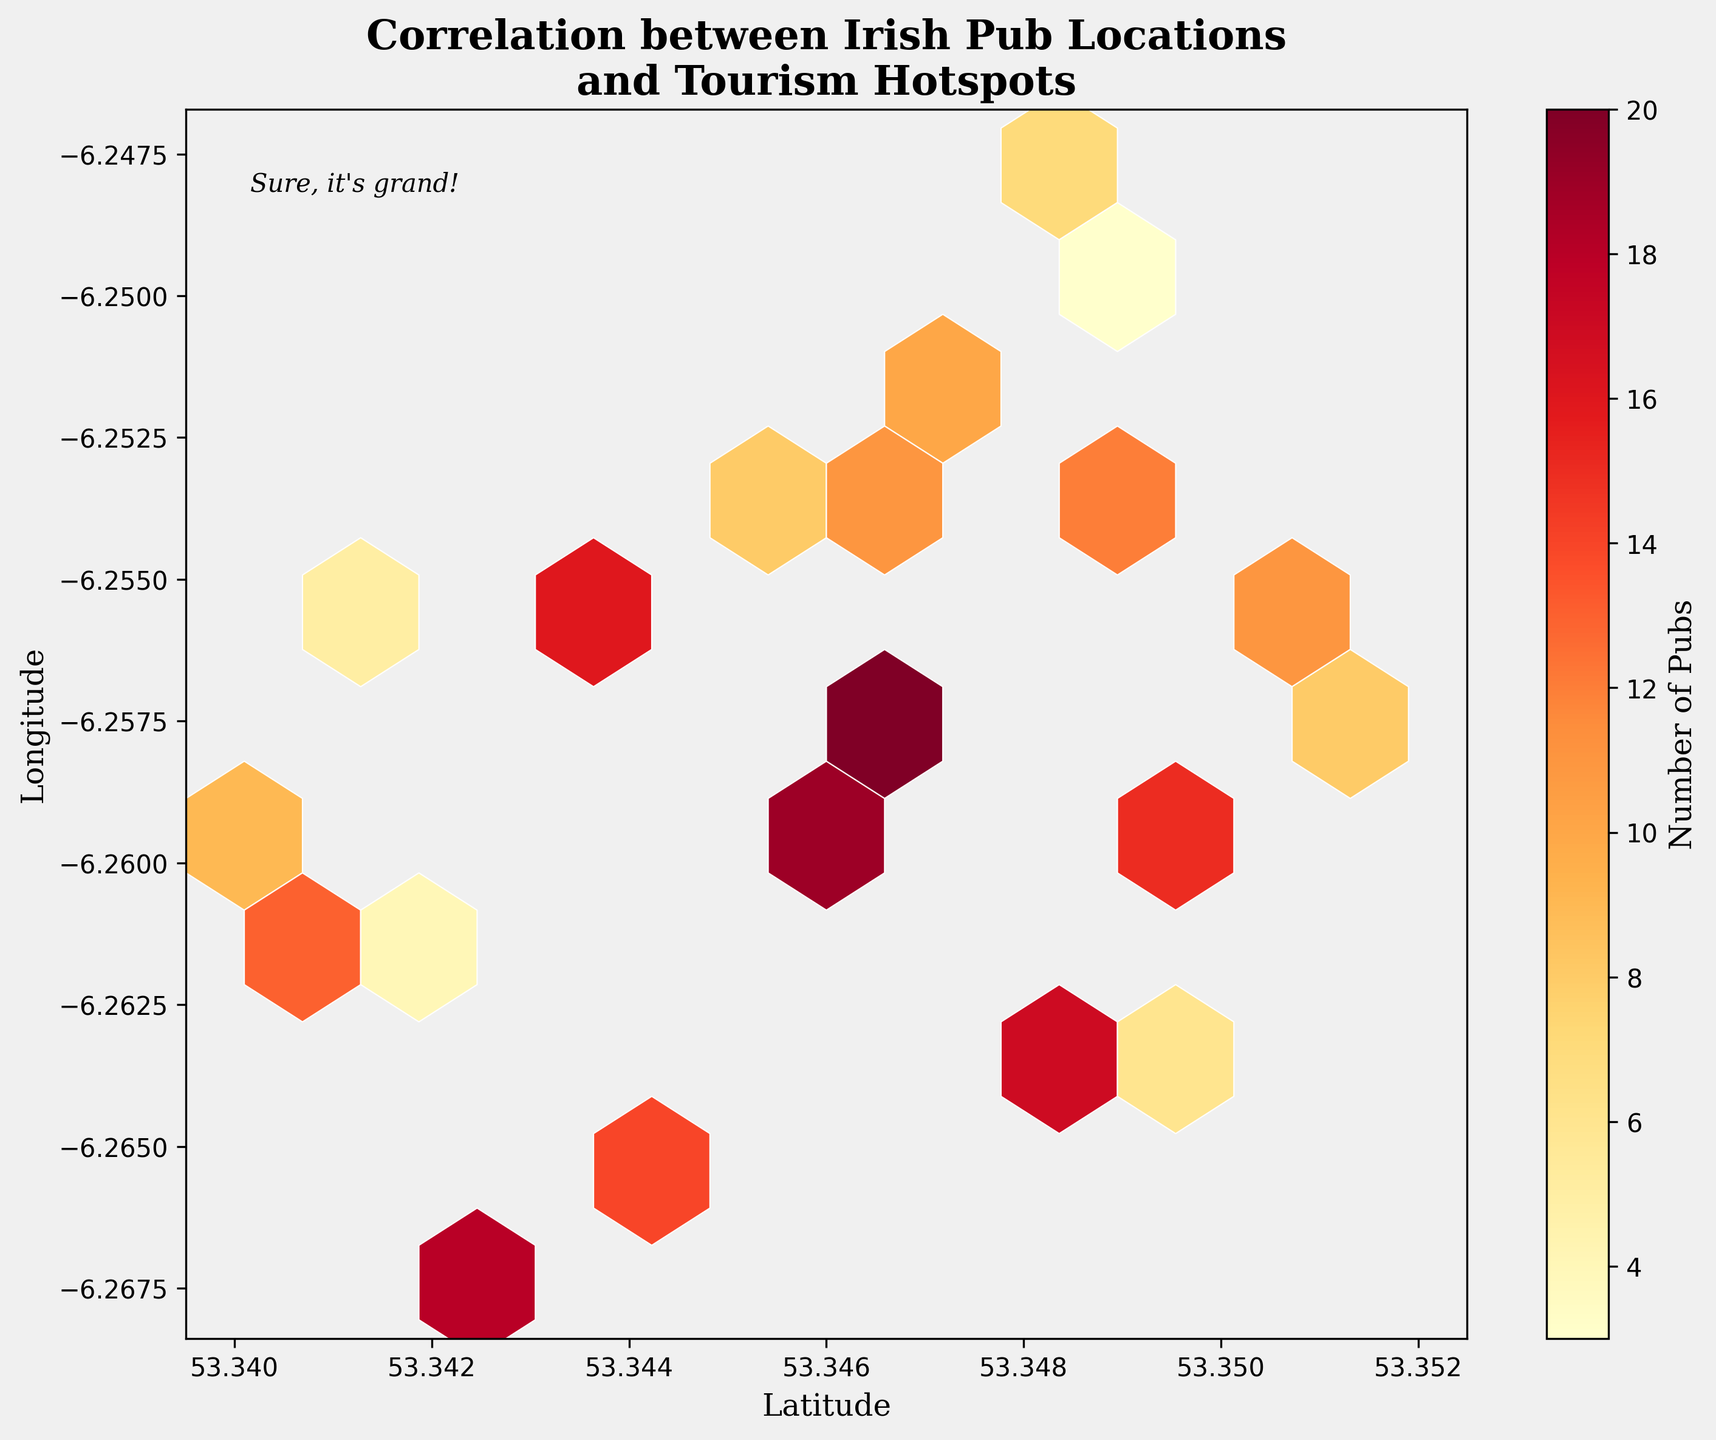What is the title of the figure? The title is prominently displayed at the top of the figure.
Answer: Correlation between Irish Pub Locations and Tourism Hotspots What color is used for the highest density of pubs? The color bar on the right indicates that the highest density of pubs is represented by the darkest hue on the yellow-orange-red spectrum.
Answer: Red How many data points are depicted in the figure? Each hexagon might represent multiple data points, but the total number is shown in the data list.
Answer: 20 What does the color bar represent? The color bar indicates the number of pubs, from the lightest color indicating fewer pubs to the darkest color indicating the most pubs.
Answer: Number of Pubs Which axis represents latitude? The axis labels help us identify which axis corresponds to latitude.
Answer: The x-axis Which region has the highest concentration of pubs? Darker hexagons in the figure represent higher concentrations of pubs. We need to identify the darkest region.
Answer: Around (53.3455, -6.2601) How does the concentration of pubs around 53.3429,-6.2674 compare to 53.3495,-6.2623? We compare the shades of the hexagons at these coordinates. The darker the hexagon, the higher the concentration.
Answer: The concentration is higher around 53.3429,-6.2674 Is there any annotation on the plot? If so, what does it say? Check for any additional text on the plot and read it.
Answer: Sure, it's grand! What's the general trend regarding the correlation between pub locations and tourism hotspots based on color intensity? Observing the general distribution and the color intensities of hexagons helps in identifying whether hotspots align with high densities of pubs.
Answer: Higher density of pubs seems to correlate with tourism hotspots Estimate the approximate range of latitude values covered in the figure. Look at the x-axis and determine the starting and ending points of the range represented.
Answer: Approximately 53.34 to 53.35 